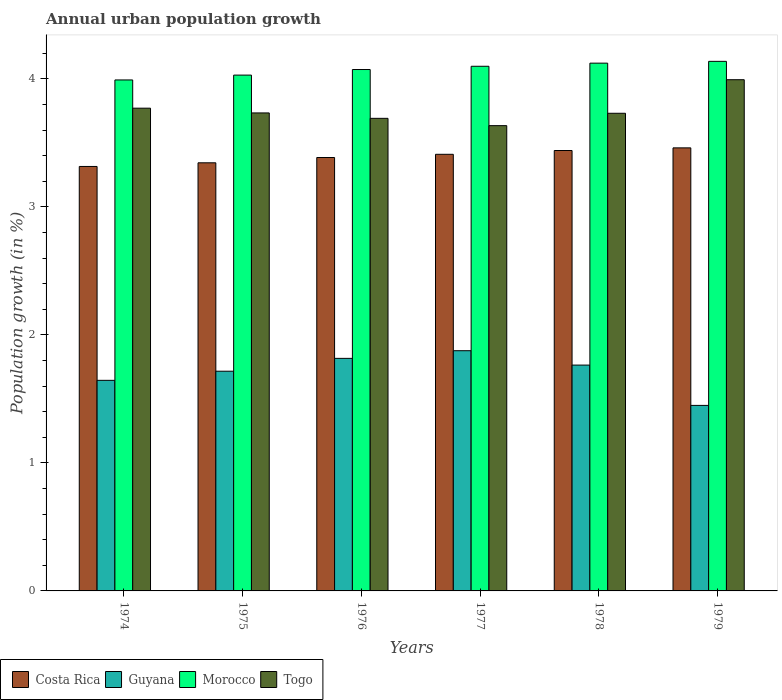How many groups of bars are there?
Make the answer very short. 6. Are the number of bars per tick equal to the number of legend labels?
Provide a short and direct response. Yes. Are the number of bars on each tick of the X-axis equal?
Provide a short and direct response. Yes. What is the label of the 5th group of bars from the left?
Keep it short and to the point. 1978. What is the percentage of urban population growth in Guyana in 1976?
Make the answer very short. 1.82. Across all years, what is the maximum percentage of urban population growth in Costa Rica?
Your answer should be very brief. 3.46. Across all years, what is the minimum percentage of urban population growth in Togo?
Keep it short and to the point. 3.64. In which year was the percentage of urban population growth in Morocco minimum?
Your answer should be compact. 1974. What is the total percentage of urban population growth in Togo in the graph?
Keep it short and to the point. 22.56. What is the difference between the percentage of urban population growth in Togo in 1975 and that in 1976?
Make the answer very short. 0.04. What is the difference between the percentage of urban population growth in Togo in 1975 and the percentage of urban population growth in Costa Rica in 1974?
Provide a short and direct response. 0.42. What is the average percentage of urban population growth in Togo per year?
Your answer should be very brief. 3.76. In the year 1977, what is the difference between the percentage of urban population growth in Guyana and percentage of urban population growth in Costa Rica?
Your response must be concise. -1.53. In how many years, is the percentage of urban population growth in Morocco greater than 2.6 %?
Give a very brief answer. 6. What is the ratio of the percentage of urban population growth in Morocco in 1974 to that in 1978?
Offer a very short reply. 0.97. Is the difference between the percentage of urban population growth in Guyana in 1976 and 1978 greater than the difference between the percentage of urban population growth in Costa Rica in 1976 and 1978?
Offer a very short reply. Yes. What is the difference between the highest and the second highest percentage of urban population growth in Costa Rica?
Your answer should be compact. 0.02. What is the difference between the highest and the lowest percentage of urban population growth in Morocco?
Keep it short and to the point. 0.15. Is the sum of the percentage of urban population growth in Morocco in 1974 and 1979 greater than the maximum percentage of urban population growth in Costa Rica across all years?
Ensure brevity in your answer.  Yes. What does the 3rd bar from the left in 1976 represents?
Give a very brief answer. Morocco. What does the 3rd bar from the right in 1977 represents?
Give a very brief answer. Guyana. Are the values on the major ticks of Y-axis written in scientific E-notation?
Give a very brief answer. No. How are the legend labels stacked?
Provide a succinct answer. Horizontal. What is the title of the graph?
Keep it short and to the point. Annual urban population growth. Does "Kazakhstan" appear as one of the legend labels in the graph?
Ensure brevity in your answer.  No. What is the label or title of the X-axis?
Keep it short and to the point. Years. What is the label or title of the Y-axis?
Make the answer very short. Population growth (in %). What is the Population growth (in %) of Costa Rica in 1974?
Your answer should be very brief. 3.32. What is the Population growth (in %) of Guyana in 1974?
Your response must be concise. 1.65. What is the Population growth (in %) in Morocco in 1974?
Keep it short and to the point. 3.99. What is the Population growth (in %) of Togo in 1974?
Ensure brevity in your answer.  3.77. What is the Population growth (in %) in Costa Rica in 1975?
Make the answer very short. 3.34. What is the Population growth (in %) in Guyana in 1975?
Your response must be concise. 1.72. What is the Population growth (in %) of Morocco in 1975?
Offer a terse response. 4.03. What is the Population growth (in %) in Togo in 1975?
Your answer should be very brief. 3.73. What is the Population growth (in %) of Costa Rica in 1976?
Offer a terse response. 3.39. What is the Population growth (in %) of Guyana in 1976?
Ensure brevity in your answer.  1.82. What is the Population growth (in %) of Morocco in 1976?
Your answer should be very brief. 4.07. What is the Population growth (in %) of Togo in 1976?
Provide a short and direct response. 3.69. What is the Population growth (in %) of Costa Rica in 1977?
Provide a succinct answer. 3.41. What is the Population growth (in %) in Guyana in 1977?
Your answer should be very brief. 1.88. What is the Population growth (in %) in Morocco in 1977?
Offer a very short reply. 4.1. What is the Population growth (in %) in Togo in 1977?
Offer a terse response. 3.64. What is the Population growth (in %) of Costa Rica in 1978?
Offer a very short reply. 3.44. What is the Population growth (in %) in Guyana in 1978?
Offer a very short reply. 1.76. What is the Population growth (in %) of Morocco in 1978?
Provide a succinct answer. 4.12. What is the Population growth (in %) in Togo in 1978?
Offer a very short reply. 3.73. What is the Population growth (in %) in Costa Rica in 1979?
Offer a very short reply. 3.46. What is the Population growth (in %) in Guyana in 1979?
Provide a succinct answer. 1.45. What is the Population growth (in %) of Morocco in 1979?
Provide a short and direct response. 4.14. What is the Population growth (in %) in Togo in 1979?
Make the answer very short. 3.99. Across all years, what is the maximum Population growth (in %) in Costa Rica?
Your response must be concise. 3.46. Across all years, what is the maximum Population growth (in %) of Guyana?
Offer a very short reply. 1.88. Across all years, what is the maximum Population growth (in %) in Morocco?
Offer a terse response. 4.14. Across all years, what is the maximum Population growth (in %) in Togo?
Make the answer very short. 3.99. Across all years, what is the minimum Population growth (in %) of Costa Rica?
Make the answer very short. 3.32. Across all years, what is the minimum Population growth (in %) of Guyana?
Provide a succinct answer. 1.45. Across all years, what is the minimum Population growth (in %) in Morocco?
Ensure brevity in your answer.  3.99. Across all years, what is the minimum Population growth (in %) of Togo?
Give a very brief answer. 3.64. What is the total Population growth (in %) of Costa Rica in the graph?
Offer a terse response. 20.36. What is the total Population growth (in %) in Guyana in the graph?
Offer a very short reply. 10.27. What is the total Population growth (in %) of Morocco in the graph?
Provide a short and direct response. 24.46. What is the total Population growth (in %) in Togo in the graph?
Offer a terse response. 22.56. What is the difference between the Population growth (in %) in Costa Rica in 1974 and that in 1975?
Your response must be concise. -0.03. What is the difference between the Population growth (in %) of Guyana in 1974 and that in 1975?
Provide a short and direct response. -0.07. What is the difference between the Population growth (in %) of Morocco in 1974 and that in 1975?
Make the answer very short. -0.04. What is the difference between the Population growth (in %) in Togo in 1974 and that in 1975?
Provide a short and direct response. 0.04. What is the difference between the Population growth (in %) of Costa Rica in 1974 and that in 1976?
Give a very brief answer. -0.07. What is the difference between the Population growth (in %) of Guyana in 1974 and that in 1976?
Provide a short and direct response. -0.17. What is the difference between the Population growth (in %) of Morocco in 1974 and that in 1976?
Give a very brief answer. -0.08. What is the difference between the Population growth (in %) of Togo in 1974 and that in 1976?
Provide a short and direct response. 0.08. What is the difference between the Population growth (in %) in Costa Rica in 1974 and that in 1977?
Provide a short and direct response. -0.1. What is the difference between the Population growth (in %) of Guyana in 1974 and that in 1977?
Offer a very short reply. -0.23. What is the difference between the Population growth (in %) of Morocco in 1974 and that in 1977?
Offer a terse response. -0.11. What is the difference between the Population growth (in %) of Togo in 1974 and that in 1977?
Give a very brief answer. 0.14. What is the difference between the Population growth (in %) in Costa Rica in 1974 and that in 1978?
Your answer should be very brief. -0.12. What is the difference between the Population growth (in %) of Guyana in 1974 and that in 1978?
Give a very brief answer. -0.12. What is the difference between the Population growth (in %) of Morocco in 1974 and that in 1978?
Ensure brevity in your answer.  -0.13. What is the difference between the Population growth (in %) of Togo in 1974 and that in 1978?
Give a very brief answer. 0.04. What is the difference between the Population growth (in %) of Costa Rica in 1974 and that in 1979?
Keep it short and to the point. -0.15. What is the difference between the Population growth (in %) of Guyana in 1974 and that in 1979?
Provide a succinct answer. 0.2. What is the difference between the Population growth (in %) of Morocco in 1974 and that in 1979?
Offer a very short reply. -0.15. What is the difference between the Population growth (in %) in Togo in 1974 and that in 1979?
Provide a succinct answer. -0.22. What is the difference between the Population growth (in %) in Costa Rica in 1975 and that in 1976?
Offer a terse response. -0.04. What is the difference between the Population growth (in %) of Guyana in 1975 and that in 1976?
Offer a very short reply. -0.1. What is the difference between the Population growth (in %) of Morocco in 1975 and that in 1976?
Provide a succinct answer. -0.04. What is the difference between the Population growth (in %) of Togo in 1975 and that in 1976?
Ensure brevity in your answer.  0.04. What is the difference between the Population growth (in %) of Costa Rica in 1975 and that in 1977?
Your answer should be compact. -0.07. What is the difference between the Population growth (in %) of Guyana in 1975 and that in 1977?
Ensure brevity in your answer.  -0.16. What is the difference between the Population growth (in %) of Morocco in 1975 and that in 1977?
Keep it short and to the point. -0.07. What is the difference between the Population growth (in %) in Togo in 1975 and that in 1977?
Your answer should be compact. 0.1. What is the difference between the Population growth (in %) in Costa Rica in 1975 and that in 1978?
Offer a very short reply. -0.1. What is the difference between the Population growth (in %) of Guyana in 1975 and that in 1978?
Give a very brief answer. -0.05. What is the difference between the Population growth (in %) in Morocco in 1975 and that in 1978?
Your answer should be compact. -0.09. What is the difference between the Population growth (in %) of Togo in 1975 and that in 1978?
Provide a short and direct response. 0. What is the difference between the Population growth (in %) in Costa Rica in 1975 and that in 1979?
Provide a short and direct response. -0.12. What is the difference between the Population growth (in %) of Guyana in 1975 and that in 1979?
Ensure brevity in your answer.  0.27. What is the difference between the Population growth (in %) of Morocco in 1975 and that in 1979?
Make the answer very short. -0.11. What is the difference between the Population growth (in %) in Togo in 1975 and that in 1979?
Keep it short and to the point. -0.26. What is the difference between the Population growth (in %) in Costa Rica in 1976 and that in 1977?
Offer a terse response. -0.03. What is the difference between the Population growth (in %) in Guyana in 1976 and that in 1977?
Give a very brief answer. -0.06. What is the difference between the Population growth (in %) of Morocco in 1976 and that in 1977?
Offer a very short reply. -0.03. What is the difference between the Population growth (in %) in Togo in 1976 and that in 1977?
Offer a terse response. 0.06. What is the difference between the Population growth (in %) in Costa Rica in 1976 and that in 1978?
Provide a short and direct response. -0.05. What is the difference between the Population growth (in %) in Guyana in 1976 and that in 1978?
Ensure brevity in your answer.  0.05. What is the difference between the Population growth (in %) of Morocco in 1976 and that in 1978?
Provide a short and direct response. -0.05. What is the difference between the Population growth (in %) of Togo in 1976 and that in 1978?
Provide a short and direct response. -0.04. What is the difference between the Population growth (in %) of Costa Rica in 1976 and that in 1979?
Offer a very short reply. -0.08. What is the difference between the Population growth (in %) of Guyana in 1976 and that in 1979?
Give a very brief answer. 0.37. What is the difference between the Population growth (in %) of Morocco in 1976 and that in 1979?
Provide a short and direct response. -0.06. What is the difference between the Population growth (in %) of Togo in 1976 and that in 1979?
Your answer should be very brief. -0.3. What is the difference between the Population growth (in %) in Costa Rica in 1977 and that in 1978?
Make the answer very short. -0.03. What is the difference between the Population growth (in %) in Guyana in 1977 and that in 1978?
Give a very brief answer. 0.11. What is the difference between the Population growth (in %) in Morocco in 1977 and that in 1978?
Your answer should be compact. -0.02. What is the difference between the Population growth (in %) of Togo in 1977 and that in 1978?
Keep it short and to the point. -0.1. What is the difference between the Population growth (in %) in Costa Rica in 1977 and that in 1979?
Keep it short and to the point. -0.05. What is the difference between the Population growth (in %) of Guyana in 1977 and that in 1979?
Ensure brevity in your answer.  0.43. What is the difference between the Population growth (in %) in Morocco in 1977 and that in 1979?
Ensure brevity in your answer.  -0.04. What is the difference between the Population growth (in %) in Togo in 1977 and that in 1979?
Keep it short and to the point. -0.36. What is the difference between the Population growth (in %) of Costa Rica in 1978 and that in 1979?
Offer a terse response. -0.02. What is the difference between the Population growth (in %) of Guyana in 1978 and that in 1979?
Give a very brief answer. 0.32. What is the difference between the Population growth (in %) in Morocco in 1978 and that in 1979?
Ensure brevity in your answer.  -0.01. What is the difference between the Population growth (in %) of Togo in 1978 and that in 1979?
Ensure brevity in your answer.  -0.26. What is the difference between the Population growth (in %) in Costa Rica in 1974 and the Population growth (in %) in Guyana in 1975?
Your answer should be compact. 1.6. What is the difference between the Population growth (in %) of Costa Rica in 1974 and the Population growth (in %) of Morocco in 1975?
Your answer should be compact. -0.71. What is the difference between the Population growth (in %) of Costa Rica in 1974 and the Population growth (in %) of Togo in 1975?
Your response must be concise. -0.42. What is the difference between the Population growth (in %) of Guyana in 1974 and the Population growth (in %) of Morocco in 1975?
Your answer should be very brief. -2.38. What is the difference between the Population growth (in %) of Guyana in 1974 and the Population growth (in %) of Togo in 1975?
Your response must be concise. -2.09. What is the difference between the Population growth (in %) in Morocco in 1974 and the Population growth (in %) in Togo in 1975?
Make the answer very short. 0.26. What is the difference between the Population growth (in %) in Costa Rica in 1974 and the Population growth (in %) in Guyana in 1976?
Provide a short and direct response. 1.5. What is the difference between the Population growth (in %) in Costa Rica in 1974 and the Population growth (in %) in Morocco in 1976?
Offer a terse response. -0.76. What is the difference between the Population growth (in %) of Costa Rica in 1974 and the Population growth (in %) of Togo in 1976?
Make the answer very short. -0.38. What is the difference between the Population growth (in %) of Guyana in 1974 and the Population growth (in %) of Morocco in 1976?
Give a very brief answer. -2.43. What is the difference between the Population growth (in %) in Guyana in 1974 and the Population growth (in %) in Togo in 1976?
Give a very brief answer. -2.05. What is the difference between the Population growth (in %) of Morocco in 1974 and the Population growth (in %) of Togo in 1976?
Your answer should be very brief. 0.3. What is the difference between the Population growth (in %) in Costa Rica in 1974 and the Population growth (in %) in Guyana in 1977?
Keep it short and to the point. 1.44. What is the difference between the Population growth (in %) of Costa Rica in 1974 and the Population growth (in %) of Morocco in 1977?
Keep it short and to the point. -0.78. What is the difference between the Population growth (in %) of Costa Rica in 1974 and the Population growth (in %) of Togo in 1977?
Keep it short and to the point. -0.32. What is the difference between the Population growth (in %) of Guyana in 1974 and the Population growth (in %) of Morocco in 1977?
Ensure brevity in your answer.  -2.45. What is the difference between the Population growth (in %) in Guyana in 1974 and the Population growth (in %) in Togo in 1977?
Keep it short and to the point. -1.99. What is the difference between the Population growth (in %) in Morocco in 1974 and the Population growth (in %) in Togo in 1977?
Ensure brevity in your answer.  0.36. What is the difference between the Population growth (in %) of Costa Rica in 1974 and the Population growth (in %) of Guyana in 1978?
Provide a succinct answer. 1.55. What is the difference between the Population growth (in %) of Costa Rica in 1974 and the Population growth (in %) of Morocco in 1978?
Provide a short and direct response. -0.81. What is the difference between the Population growth (in %) in Costa Rica in 1974 and the Population growth (in %) in Togo in 1978?
Ensure brevity in your answer.  -0.42. What is the difference between the Population growth (in %) in Guyana in 1974 and the Population growth (in %) in Morocco in 1978?
Offer a very short reply. -2.48. What is the difference between the Population growth (in %) in Guyana in 1974 and the Population growth (in %) in Togo in 1978?
Keep it short and to the point. -2.09. What is the difference between the Population growth (in %) in Morocco in 1974 and the Population growth (in %) in Togo in 1978?
Give a very brief answer. 0.26. What is the difference between the Population growth (in %) of Costa Rica in 1974 and the Population growth (in %) of Guyana in 1979?
Provide a succinct answer. 1.87. What is the difference between the Population growth (in %) in Costa Rica in 1974 and the Population growth (in %) in Morocco in 1979?
Keep it short and to the point. -0.82. What is the difference between the Population growth (in %) in Costa Rica in 1974 and the Population growth (in %) in Togo in 1979?
Make the answer very short. -0.68. What is the difference between the Population growth (in %) in Guyana in 1974 and the Population growth (in %) in Morocco in 1979?
Your answer should be compact. -2.49. What is the difference between the Population growth (in %) of Guyana in 1974 and the Population growth (in %) of Togo in 1979?
Your answer should be compact. -2.35. What is the difference between the Population growth (in %) in Morocco in 1974 and the Population growth (in %) in Togo in 1979?
Give a very brief answer. -0. What is the difference between the Population growth (in %) of Costa Rica in 1975 and the Population growth (in %) of Guyana in 1976?
Provide a short and direct response. 1.53. What is the difference between the Population growth (in %) of Costa Rica in 1975 and the Population growth (in %) of Morocco in 1976?
Make the answer very short. -0.73. What is the difference between the Population growth (in %) of Costa Rica in 1975 and the Population growth (in %) of Togo in 1976?
Provide a short and direct response. -0.35. What is the difference between the Population growth (in %) in Guyana in 1975 and the Population growth (in %) in Morocco in 1976?
Your response must be concise. -2.36. What is the difference between the Population growth (in %) in Guyana in 1975 and the Population growth (in %) in Togo in 1976?
Provide a succinct answer. -1.98. What is the difference between the Population growth (in %) of Morocco in 1975 and the Population growth (in %) of Togo in 1976?
Provide a short and direct response. 0.34. What is the difference between the Population growth (in %) of Costa Rica in 1975 and the Population growth (in %) of Guyana in 1977?
Offer a terse response. 1.47. What is the difference between the Population growth (in %) in Costa Rica in 1975 and the Population growth (in %) in Morocco in 1977?
Your response must be concise. -0.75. What is the difference between the Population growth (in %) of Costa Rica in 1975 and the Population growth (in %) of Togo in 1977?
Keep it short and to the point. -0.29. What is the difference between the Population growth (in %) of Guyana in 1975 and the Population growth (in %) of Morocco in 1977?
Offer a terse response. -2.38. What is the difference between the Population growth (in %) in Guyana in 1975 and the Population growth (in %) in Togo in 1977?
Offer a terse response. -1.92. What is the difference between the Population growth (in %) of Morocco in 1975 and the Population growth (in %) of Togo in 1977?
Give a very brief answer. 0.39. What is the difference between the Population growth (in %) in Costa Rica in 1975 and the Population growth (in %) in Guyana in 1978?
Make the answer very short. 1.58. What is the difference between the Population growth (in %) of Costa Rica in 1975 and the Population growth (in %) of Morocco in 1978?
Your answer should be compact. -0.78. What is the difference between the Population growth (in %) in Costa Rica in 1975 and the Population growth (in %) in Togo in 1978?
Your response must be concise. -0.39. What is the difference between the Population growth (in %) in Guyana in 1975 and the Population growth (in %) in Morocco in 1978?
Your answer should be very brief. -2.41. What is the difference between the Population growth (in %) in Guyana in 1975 and the Population growth (in %) in Togo in 1978?
Your answer should be compact. -2.02. What is the difference between the Population growth (in %) of Morocco in 1975 and the Population growth (in %) of Togo in 1978?
Your answer should be compact. 0.3. What is the difference between the Population growth (in %) in Costa Rica in 1975 and the Population growth (in %) in Guyana in 1979?
Provide a succinct answer. 1.9. What is the difference between the Population growth (in %) in Costa Rica in 1975 and the Population growth (in %) in Morocco in 1979?
Offer a terse response. -0.79. What is the difference between the Population growth (in %) of Costa Rica in 1975 and the Population growth (in %) of Togo in 1979?
Make the answer very short. -0.65. What is the difference between the Population growth (in %) of Guyana in 1975 and the Population growth (in %) of Morocco in 1979?
Make the answer very short. -2.42. What is the difference between the Population growth (in %) in Guyana in 1975 and the Population growth (in %) in Togo in 1979?
Provide a succinct answer. -2.28. What is the difference between the Population growth (in %) of Morocco in 1975 and the Population growth (in %) of Togo in 1979?
Keep it short and to the point. 0.04. What is the difference between the Population growth (in %) in Costa Rica in 1976 and the Population growth (in %) in Guyana in 1977?
Make the answer very short. 1.51. What is the difference between the Population growth (in %) in Costa Rica in 1976 and the Population growth (in %) in Morocco in 1977?
Your answer should be very brief. -0.71. What is the difference between the Population growth (in %) in Costa Rica in 1976 and the Population growth (in %) in Togo in 1977?
Keep it short and to the point. -0.25. What is the difference between the Population growth (in %) of Guyana in 1976 and the Population growth (in %) of Morocco in 1977?
Your response must be concise. -2.28. What is the difference between the Population growth (in %) of Guyana in 1976 and the Population growth (in %) of Togo in 1977?
Make the answer very short. -1.82. What is the difference between the Population growth (in %) in Morocco in 1976 and the Population growth (in %) in Togo in 1977?
Your answer should be compact. 0.44. What is the difference between the Population growth (in %) of Costa Rica in 1976 and the Population growth (in %) of Guyana in 1978?
Give a very brief answer. 1.62. What is the difference between the Population growth (in %) in Costa Rica in 1976 and the Population growth (in %) in Morocco in 1978?
Provide a short and direct response. -0.74. What is the difference between the Population growth (in %) in Costa Rica in 1976 and the Population growth (in %) in Togo in 1978?
Make the answer very short. -0.35. What is the difference between the Population growth (in %) in Guyana in 1976 and the Population growth (in %) in Morocco in 1978?
Offer a very short reply. -2.31. What is the difference between the Population growth (in %) of Guyana in 1976 and the Population growth (in %) of Togo in 1978?
Offer a terse response. -1.91. What is the difference between the Population growth (in %) of Morocco in 1976 and the Population growth (in %) of Togo in 1978?
Your response must be concise. 0.34. What is the difference between the Population growth (in %) in Costa Rica in 1976 and the Population growth (in %) in Guyana in 1979?
Give a very brief answer. 1.94. What is the difference between the Population growth (in %) in Costa Rica in 1976 and the Population growth (in %) in Morocco in 1979?
Ensure brevity in your answer.  -0.75. What is the difference between the Population growth (in %) in Costa Rica in 1976 and the Population growth (in %) in Togo in 1979?
Offer a very short reply. -0.61. What is the difference between the Population growth (in %) of Guyana in 1976 and the Population growth (in %) of Morocco in 1979?
Offer a terse response. -2.32. What is the difference between the Population growth (in %) of Guyana in 1976 and the Population growth (in %) of Togo in 1979?
Your answer should be compact. -2.18. What is the difference between the Population growth (in %) in Morocco in 1976 and the Population growth (in %) in Togo in 1979?
Your response must be concise. 0.08. What is the difference between the Population growth (in %) of Costa Rica in 1977 and the Population growth (in %) of Guyana in 1978?
Keep it short and to the point. 1.65. What is the difference between the Population growth (in %) in Costa Rica in 1977 and the Population growth (in %) in Morocco in 1978?
Keep it short and to the point. -0.71. What is the difference between the Population growth (in %) of Costa Rica in 1977 and the Population growth (in %) of Togo in 1978?
Ensure brevity in your answer.  -0.32. What is the difference between the Population growth (in %) in Guyana in 1977 and the Population growth (in %) in Morocco in 1978?
Keep it short and to the point. -2.25. What is the difference between the Population growth (in %) of Guyana in 1977 and the Population growth (in %) of Togo in 1978?
Offer a very short reply. -1.86. What is the difference between the Population growth (in %) in Morocco in 1977 and the Population growth (in %) in Togo in 1978?
Your answer should be very brief. 0.37. What is the difference between the Population growth (in %) of Costa Rica in 1977 and the Population growth (in %) of Guyana in 1979?
Provide a short and direct response. 1.96. What is the difference between the Population growth (in %) of Costa Rica in 1977 and the Population growth (in %) of Morocco in 1979?
Give a very brief answer. -0.73. What is the difference between the Population growth (in %) in Costa Rica in 1977 and the Population growth (in %) in Togo in 1979?
Offer a terse response. -0.58. What is the difference between the Population growth (in %) in Guyana in 1977 and the Population growth (in %) in Morocco in 1979?
Offer a terse response. -2.26. What is the difference between the Population growth (in %) of Guyana in 1977 and the Population growth (in %) of Togo in 1979?
Your answer should be compact. -2.12. What is the difference between the Population growth (in %) in Morocco in 1977 and the Population growth (in %) in Togo in 1979?
Your answer should be very brief. 0.1. What is the difference between the Population growth (in %) in Costa Rica in 1978 and the Population growth (in %) in Guyana in 1979?
Your response must be concise. 1.99. What is the difference between the Population growth (in %) of Costa Rica in 1978 and the Population growth (in %) of Morocco in 1979?
Your answer should be compact. -0.7. What is the difference between the Population growth (in %) in Costa Rica in 1978 and the Population growth (in %) in Togo in 1979?
Ensure brevity in your answer.  -0.55. What is the difference between the Population growth (in %) in Guyana in 1978 and the Population growth (in %) in Morocco in 1979?
Provide a succinct answer. -2.37. What is the difference between the Population growth (in %) in Guyana in 1978 and the Population growth (in %) in Togo in 1979?
Ensure brevity in your answer.  -2.23. What is the difference between the Population growth (in %) of Morocco in 1978 and the Population growth (in %) of Togo in 1979?
Your answer should be very brief. 0.13. What is the average Population growth (in %) of Costa Rica per year?
Keep it short and to the point. 3.39. What is the average Population growth (in %) of Guyana per year?
Offer a terse response. 1.71. What is the average Population growth (in %) in Morocco per year?
Your response must be concise. 4.08. What is the average Population growth (in %) of Togo per year?
Your answer should be compact. 3.76. In the year 1974, what is the difference between the Population growth (in %) of Costa Rica and Population growth (in %) of Guyana?
Ensure brevity in your answer.  1.67. In the year 1974, what is the difference between the Population growth (in %) in Costa Rica and Population growth (in %) in Morocco?
Ensure brevity in your answer.  -0.68. In the year 1974, what is the difference between the Population growth (in %) in Costa Rica and Population growth (in %) in Togo?
Give a very brief answer. -0.46. In the year 1974, what is the difference between the Population growth (in %) of Guyana and Population growth (in %) of Morocco?
Make the answer very short. -2.35. In the year 1974, what is the difference between the Population growth (in %) in Guyana and Population growth (in %) in Togo?
Make the answer very short. -2.13. In the year 1974, what is the difference between the Population growth (in %) in Morocco and Population growth (in %) in Togo?
Your answer should be very brief. 0.22. In the year 1975, what is the difference between the Population growth (in %) of Costa Rica and Population growth (in %) of Guyana?
Your response must be concise. 1.63. In the year 1975, what is the difference between the Population growth (in %) of Costa Rica and Population growth (in %) of Morocco?
Provide a short and direct response. -0.69. In the year 1975, what is the difference between the Population growth (in %) of Costa Rica and Population growth (in %) of Togo?
Your answer should be very brief. -0.39. In the year 1975, what is the difference between the Population growth (in %) of Guyana and Population growth (in %) of Morocco?
Make the answer very short. -2.31. In the year 1975, what is the difference between the Population growth (in %) of Guyana and Population growth (in %) of Togo?
Give a very brief answer. -2.02. In the year 1975, what is the difference between the Population growth (in %) of Morocco and Population growth (in %) of Togo?
Keep it short and to the point. 0.3. In the year 1976, what is the difference between the Population growth (in %) in Costa Rica and Population growth (in %) in Guyana?
Make the answer very short. 1.57. In the year 1976, what is the difference between the Population growth (in %) in Costa Rica and Population growth (in %) in Morocco?
Keep it short and to the point. -0.69. In the year 1976, what is the difference between the Population growth (in %) in Costa Rica and Population growth (in %) in Togo?
Ensure brevity in your answer.  -0.31. In the year 1976, what is the difference between the Population growth (in %) in Guyana and Population growth (in %) in Morocco?
Provide a short and direct response. -2.26. In the year 1976, what is the difference between the Population growth (in %) of Guyana and Population growth (in %) of Togo?
Keep it short and to the point. -1.88. In the year 1976, what is the difference between the Population growth (in %) in Morocco and Population growth (in %) in Togo?
Give a very brief answer. 0.38. In the year 1977, what is the difference between the Population growth (in %) in Costa Rica and Population growth (in %) in Guyana?
Your answer should be compact. 1.53. In the year 1977, what is the difference between the Population growth (in %) of Costa Rica and Population growth (in %) of Morocco?
Offer a very short reply. -0.69. In the year 1977, what is the difference between the Population growth (in %) in Costa Rica and Population growth (in %) in Togo?
Your response must be concise. -0.22. In the year 1977, what is the difference between the Population growth (in %) in Guyana and Population growth (in %) in Morocco?
Your response must be concise. -2.22. In the year 1977, what is the difference between the Population growth (in %) of Guyana and Population growth (in %) of Togo?
Offer a very short reply. -1.76. In the year 1977, what is the difference between the Population growth (in %) in Morocco and Population growth (in %) in Togo?
Keep it short and to the point. 0.46. In the year 1978, what is the difference between the Population growth (in %) of Costa Rica and Population growth (in %) of Guyana?
Your answer should be very brief. 1.68. In the year 1978, what is the difference between the Population growth (in %) of Costa Rica and Population growth (in %) of Morocco?
Provide a short and direct response. -0.68. In the year 1978, what is the difference between the Population growth (in %) of Costa Rica and Population growth (in %) of Togo?
Provide a succinct answer. -0.29. In the year 1978, what is the difference between the Population growth (in %) of Guyana and Population growth (in %) of Morocco?
Keep it short and to the point. -2.36. In the year 1978, what is the difference between the Population growth (in %) of Guyana and Population growth (in %) of Togo?
Give a very brief answer. -1.97. In the year 1978, what is the difference between the Population growth (in %) of Morocco and Population growth (in %) of Togo?
Your response must be concise. 0.39. In the year 1979, what is the difference between the Population growth (in %) of Costa Rica and Population growth (in %) of Guyana?
Your response must be concise. 2.01. In the year 1979, what is the difference between the Population growth (in %) of Costa Rica and Population growth (in %) of Morocco?
Ensure brevity in your answer.  -0.68. In the year 1979, what is the difference between the Population growth (in %) in Costa Rica and Population growth (in %) in Togo?
Your answer should be compact. -0.53. In the year 1979, what is the difference between the Population growth (in %) in Guyana and Population growth (in %) in Morocco?
Your answer should be very brief. -2.69. In the year 1979, what is the difference between the Population growth (in %) of Guyana and Population growth (in %) of Togo?
Provide a short and direct response. -2.54. In the year 1979, what is the difference between the Population growth (in %) of Morocco and Population growth (in %) of Togo?
Give a very brief answer. 0.14. What is the ratio of the Population growth (in %) of Guyana in 1974 to that in 1975?
Keep it short and to the point. 0.96. What is the ratio of the Population growth (in %) of Morocco in 1974 to that in 1975?
Your response must be concise. 0.99. What is the ratio of the Population growth (in %) in Togo in 1974 to that in 1975?
Your response must be concise. 1.01. What is the ratio of the Population growth (in %) of Costa Rica in 1974 to that in 1976?
Provide a short and direct response. 0.98. What is the ratio of the Population growth (in %) of Guyana in 1974 to that in 1976?
Ensure brevity in your answer.  0.91. What is the ratio of the Population growth (in %) of Morocco in 1974 to that in 1976?
Offer a very short reply. 0.98. What is the ratio of the Population growth (in %) in Togo in 1974 to that in 1976?
Offer a terse response. 1.02. What is the ratio of the Population growth (in %) of Costa Rica in 1974 to that in 1977?
Offer a very short reply. 0.97. What is the ratio of the Population growth (in %) of Guyana in 1974 to that in 1977?
Offer a terse response. 0.88. What is the ratio of the Population growth (in %) in Morocco in 1974 to that in 1977?
Keep it short and to the point. 0.97. What is the ratio of the Population growth (in %) of Togo in 1974 to that in 1977?
Ensure brevity in your answer.  1.04. What is the ratio of the Population growth (in %) of Costa Rica in 1974 to that in 1978?
Provide a succinct answer. 0.96. What is the ratio of the Population growth (in %) of Guyana in 1974 to that in 1978?
Provide a succinct answer. 0.93. What is the ratio of the Population growth (in %) in Morocco in 1974 to that in 1978?
Your response must be concise. 0.97. What is the ratio of the Population growth (in %) of Togo in 1974 to that in 1978?
Offer a very short reply. 1.01. What is the ratio of the Population growth (in %) of Costa Rica in 1974 to that in 1979?
Your answer should be compact. 0.96. What is the ratio of the Population growth (in %) in Guyana in 1974 to that in 1979?
Provide a short and direct response. 1.14. What is the ratio of the Population growth (in %) of Morocco in 1974 to that in 1979?
Your response must be concise. 0.96. What is the ratio of the Population growth (in %) in Togo in 1974 to that in 1979?
Ensure brevity in your answer.  0.94. What is the ratio of the Population growth (in %) of Costa Rica in 1975 to that in 1976?
Offer a very short reply. 0.99. What is the ratio of the Population growth (in %) in Guyana in 1975 to that in 1976?
Make the answer very short. 0.94. What is the ratio of the Population growth (in %) in Morocco in 1975 to that in 1976?
Offer a terse response. 0.99. What is the ratio of the Population growth (in %) of Togo in 1975 to that in 1976?
Your answer should be compact. 1.01. What is the ratio of the Population growth (in %) in Costa Rica in 1975 to that in 1977?
Keep it short and to the point. 0.98. What is the ratio of the Population growth (in %) in Guyana in 1975 to that in 1977?
Make the answer very short. 0.91. What is the ratio of the Population growth (in %) in Morocco in 1975 to that in 1977?
Your answer should be very brief. 0.98. What is the ratio of the Population growth (in %) of Togo in 1975 to that in 1977?
Your answer should be compact. 1.03. What is the ratio of the Population growth (in %) in Costa Rica in 1975 to that in 1978?
Provide a short and direct response. 0.97. What is the ratio of the Population growth (in %) in Guyana in 1975 to that in 1978?
Make the answer very short. 0.97. What is the ratio of the Population growth (in %) of Morocco in 1975 to that in 1978?
Keep it short and to the point. 0.98. What is the ratio of the Population growth (in %) in Togo in 1975 to that in 1978?
Keep it short and to the point. 1. What is the ratio of the Population growth (in %) of Costa Rica in 1975 to that in 1979?
Your answer should be compact. 0.97. What is the ratio of the Population growth (in %) in Guyana in 1975 to that in 1979?
Your response must be concise. 1.18. What is the ratio of the Population growth (in %) of Morocco in 1975 to that in 1979?
Give a very brief answer. 0.97. What is the ratio of the Population growth (in %) of Togo in 1975 to that in 1979?
Your response must be concise. 0.94. What is the ratio of the Population growth (in %) of Guyana in 1976 to that in 1977?
Your response must be concise. 0.97. What is the ratio of the Population growth (in %) of Morocco in 1976 to that in 1977?
Give a very brief answer. 0.99. What is the ratio of the Population growth (in %) of Togo in 1976 to that in 1977?
Your answer should be very brief. 1.02. What is the ratio of the Population growth (in %) of Costa Rica in 1976 to that in 1978?
Make the answer very short. 0.98. What is the ratio of the Population growth (in %) of Guyana in 1976 to that in 1978?
Your response must be concise. 1.03. What is the ratio of the Population growth (in %) of Morocco in 1976 to that in 1978?
Give a very brief answer. 0.99. What is the ratio of the Population growth (in %) of Costa Rica in 1976 to that in 1979?
Provide a succinct answer. 0.98. What is the ratio of the Population growth (in %) in Guyana in 1976 to that in 1979?
Provide a succinct answer. 1.25. What is the ratio of the Population growth (in %) of Morocco in 1976 to that in 1979?
Ensure brevity in your answer.  0.98. What is the ratio of the Population growth (in %) in Togo in 1976 to that in 1979?
Offer a very short reply. 0.92. What is the ratio of the Population growth (in %) in Guyana in 1977 to that in 1978?
Provide a succinct answer. 1.06. What is the ratio of the Population growth (in %) in Togo in 1977 to that in 1978?
Offer a very short reply. 0.97. What is the ratio of the Population growth (in %) in Costa Rica in 1977 to that in 1979?
Provide a short and direct response. 0.99. What is the ratio of the Population growth (in %) of Guyana in 1977 to that in 1979?
Give a very brief answer. 1.29. What is the ratio of the Population growth (in %) of Togo in 1977 to that in 1979?
Provide a short and direct response. 0.91. What is the ratio of the Population growth (in %) in Guyana in 1978 to that in 1979?
Your response must be concise. 1.22. What is the ratio of the Population growth (in %) of Morocco in 1978 to that in 1979?
Your response must be concise. 1. What is the ratio of the Population growth (in %) in Togo in 1978 to that in 1979?
Your answer should be compact. 0.93. What is the difference between the highest and the second highest Population growth (in %) of Costa Rica?
Your answer should be compact. 0.02. What is the difference between the highest and the second highest Population growth (in %) of Guyana?
Make the answer very short. 0.06. What is the difference between the highest and the second highest Population growth (in %) in Morocco?
Your response must be concise. 0.01. What is the difference between the highest and the second highest Population growth (in %) in Togo?
Give a very brief answer. 0.22. What is the difference between the highest and the lowest Population growth (in %) in Costa Rica?
Provide a short and direct response. 0.15. What is the difference between the highest and the lowest Population growth (in %) in Guyana?
Keep it short and to the point. 0.43. What is the difference between the highest and the lowest Population growth (in %) in Morocco?
Ensure brevity in your answer.  0.15. What is the difference between the highest and the lowest Population growth (in %) of Togo?
Offer a terse response. 0.36. 